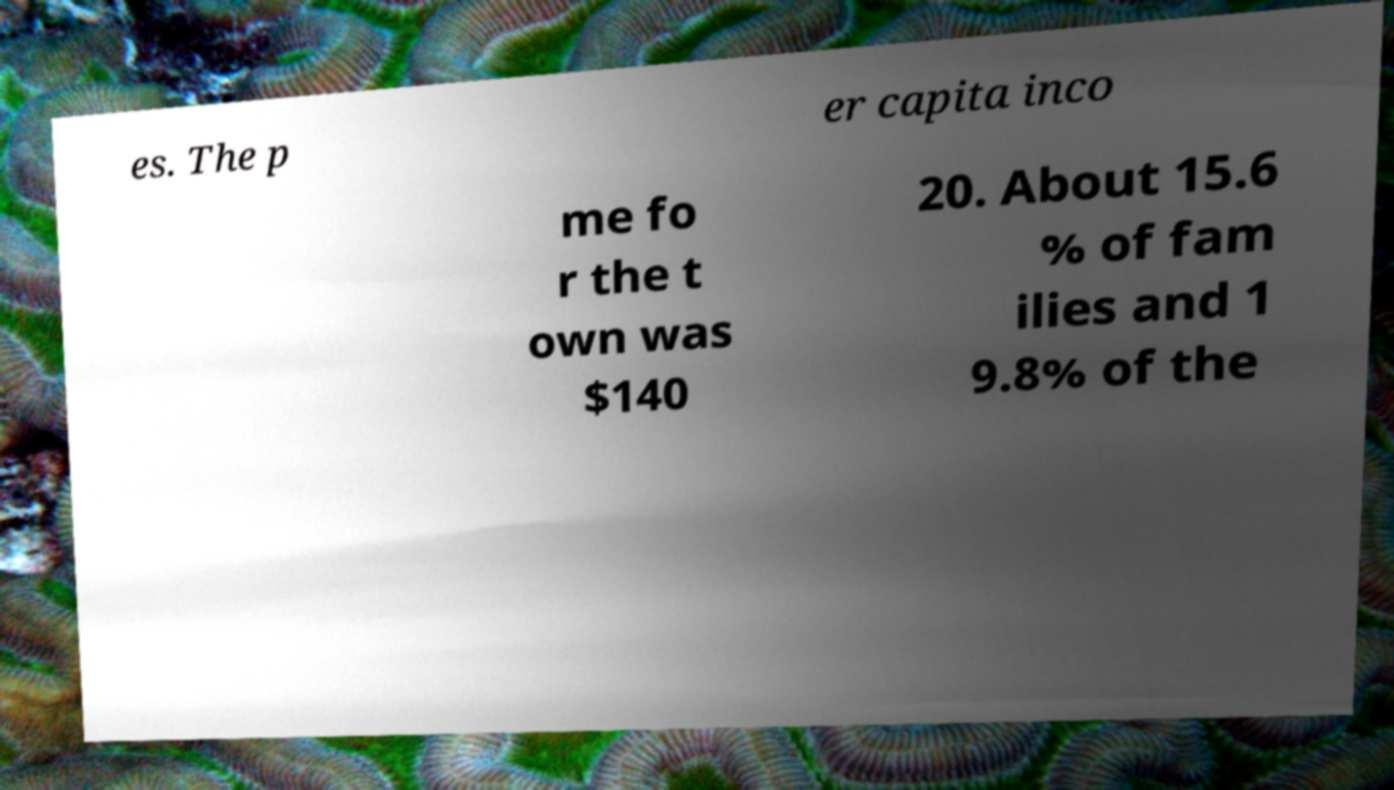Can you accurately transcribe the text from the provided image for me? es. The p er capita inco me fo r the t own was $140 20. About 15.6 % of fam ilies and 1 9.8% of the 